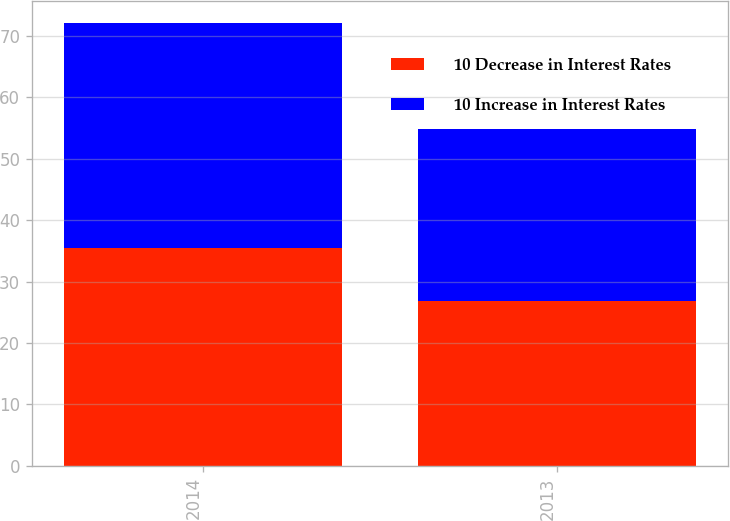<chart> <loc_0><loc_0><loc_500><loc_500><stacked_bar_chart><ecel><fcel>2014<fcel>2013<nl><fcel>10 Decrease in Interest Rates<fcel>35.5<fcel>26.9<nl><fcel>10 Increase in Interest Rates<fcel>36.6<fcel>27.9<nl></chart> 